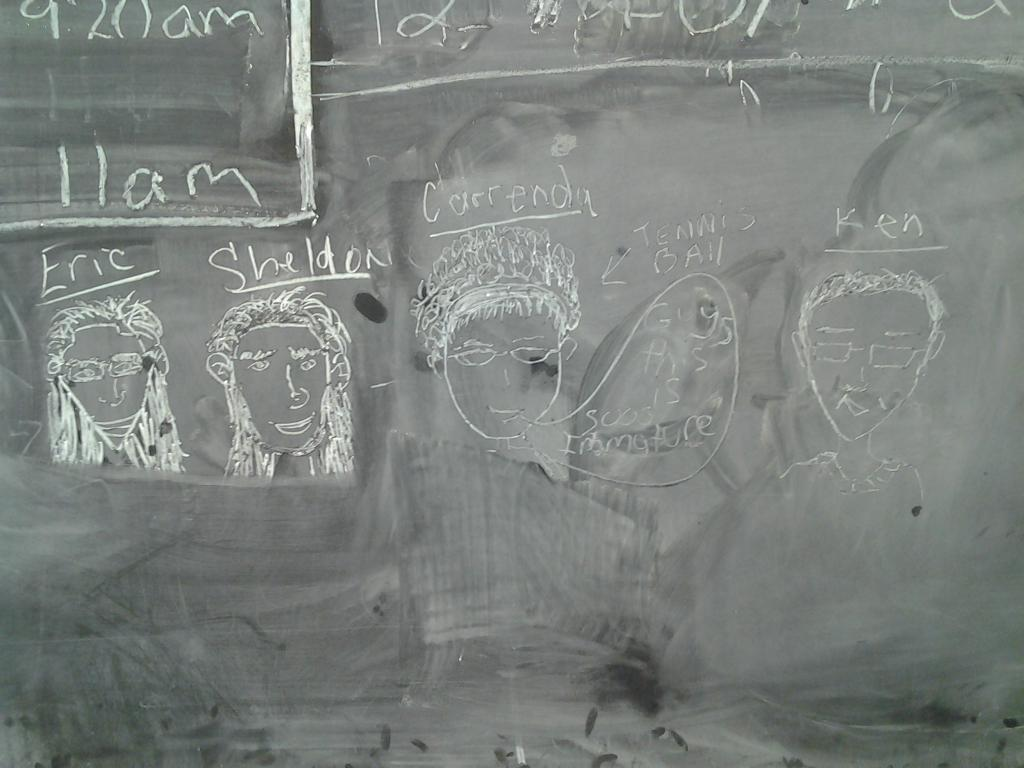What is on the blackboard in the image? There are drawings and text on the blackboard in the image. Can you see a zebra in the image? No, there is no zebra present in the image. 